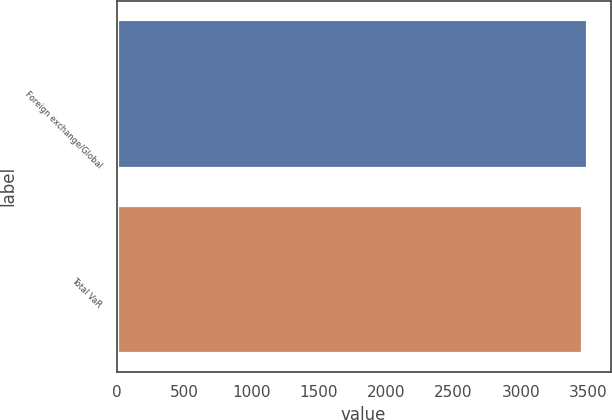<chart> <loc_0><loc_0><loc_500><loc_500><bar_chart><fcel>Foreign exchange/Global<fcel>Total VaR<nl><fcel>3492<fcel>3457<nl></chart> 